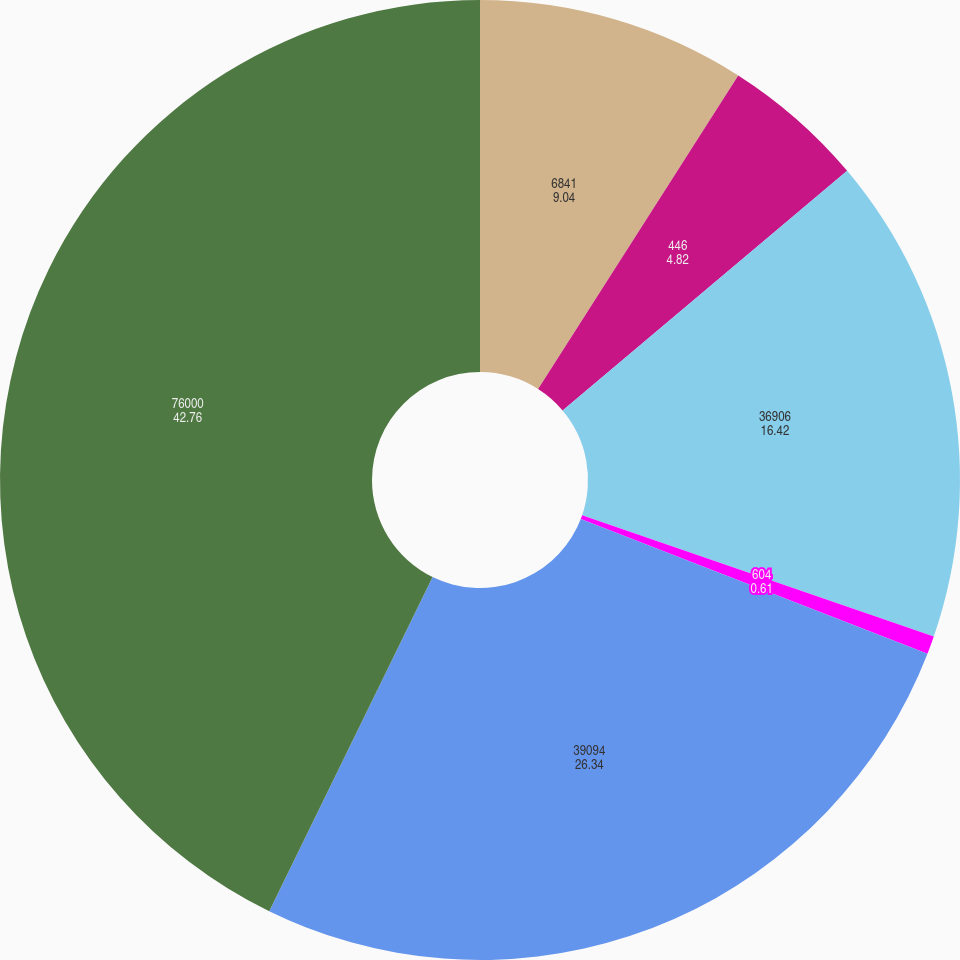Convert chart to OTSL. <chart><loc_0><loc_0><loc_500><loc_500><pie_chart><fcel>6841<fcel>446<fcel>36906<fcel>604<fcel>39094<fcel>76000<nl><fcel>9.04%<fcel>4.82%<fcel>16.42%<fcel>0.61%<fcel>26.34%<fcel>42.76%<nl></chart> 